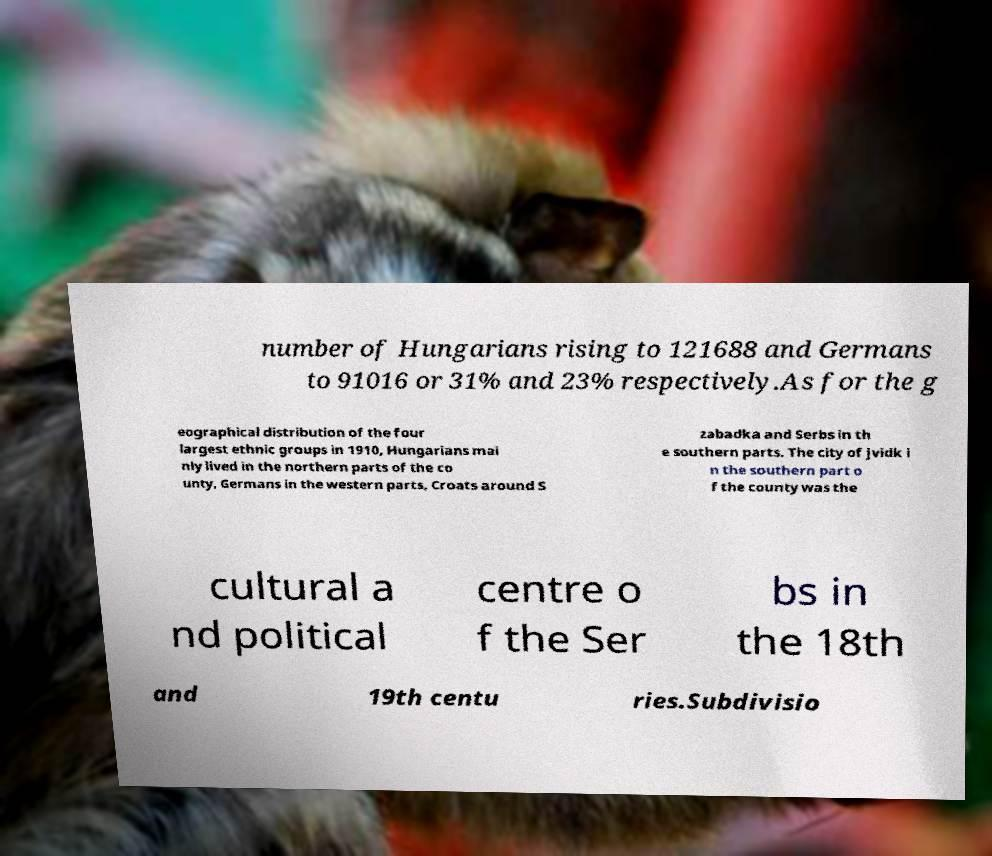Please identify and transcribe the text found in this image. number of Hungarians rising to 121688 and Germans to 91016 or 31% and 23% respectively.As for the g eographical distribution of the four largest ethnic groups in 1910, Hungarians mai nly lived in the northern parts of the co unty, Germans in the western parts, Croats around S zabadka and Serbs in th e southern parts. The city of jvidk i n the southern part o f the county was the cultural a nd political centre o f the Ser bs in the 18th and 19th centu ries.Subdivisio 